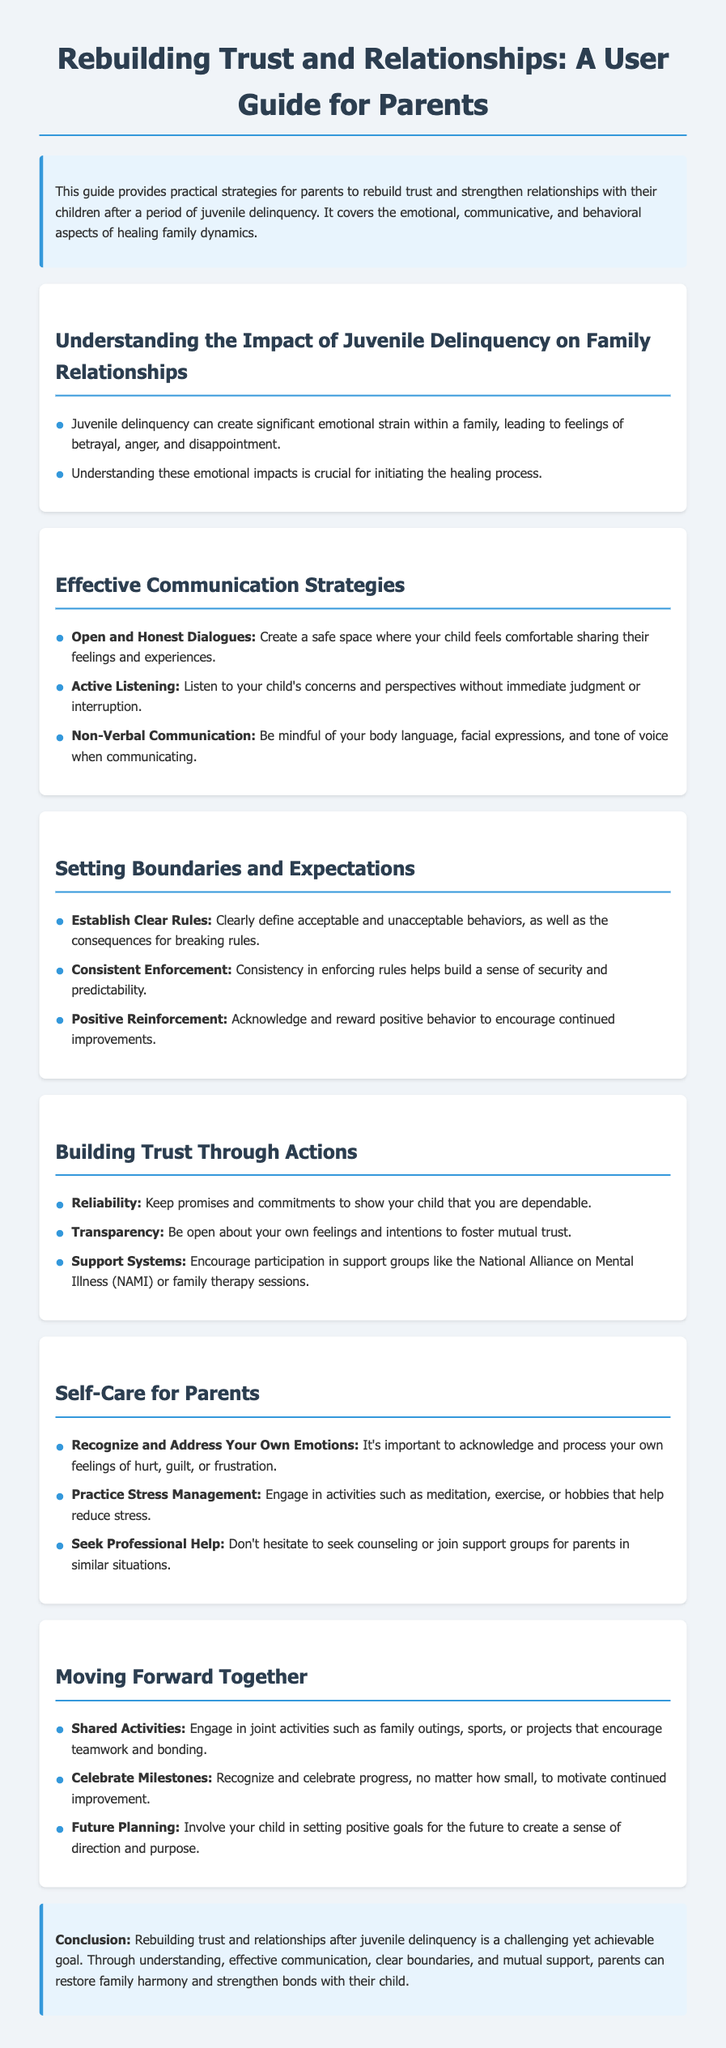What is the title of the guide? The title provides the main topic of the document which focuses on trust and relationships between parents and their children.
Answer: Rebuilding Trust and Relationships: A User Guide for Parents What is one effective communication strategy mentioned? The document outlines several strategies for communication, specifically focused on promoting open dialogue.
Answer: Open and Honest Dialogues What should parents acknowledge according to the self-care section? The self-care section emphasizes the importance of recognizing one's emotions to aid in the healing process.
Answer: Recognize and Address Your Own Emotions What are parents encouraged to join for support? The guide suggests specific support groups for parents to seek help and connect with others facing similar challenges.
Answer: National Alliance on Mental Illness (NAMI) What is a key method for parents to build trust? The document highlights specific actions, including keeping promises, as effective ways to establish trust.
Answer: Reliability What is one way to celebrate progress? Celebrating milestones is essential for motivation, as detailed in the guide.
Answer: Celebrate Milestones What color is used for the section headings? The section headings are consistently styled to maintain visual coherence throughout the guide.
Answer: #2c3e50 How many sections are in the document? The document notably organizes its content into distinct sections offering various strategies and advice.
Answer: Six 